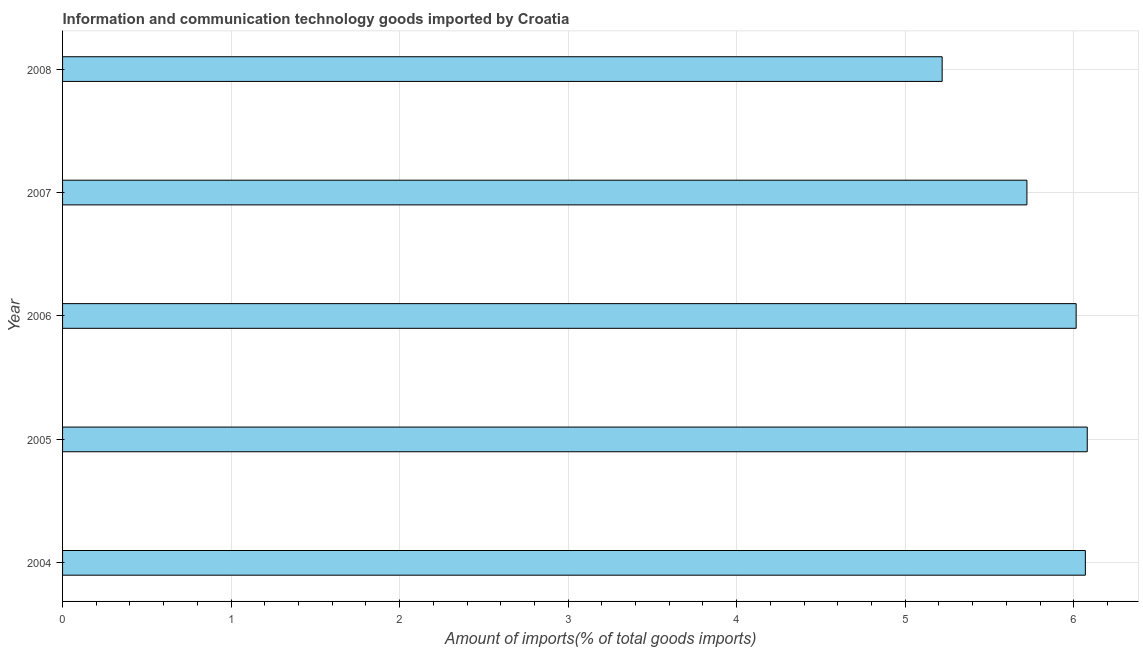Does the graph contain any zero values?
Your answer should be very brief. No. Does the graph contain grids?
Offer a terse response. Yes. What is the title of the graph?
Your answer should be compact. Information and communication technology goods imported by Croatia. What is the label or title of the X-axis?
Your response must be concise. Amount of imports(% of total goods imports). What is the label or title of the Y-axis?
Offer a terse response. Year. What is the amount of ict goods imports in 2007?
Give a very brief answer. 5.72. Across all years, what is the maximum amount of ict goods imports?
Make the answer very short. 6.08. Across all years, what is the minimum amount of ict goods imports?
Ensure brevity in your answer.  5.22. In which year was the amount of ict goods imports maximum?
Keep it short and to the point. 2005. In which year was the amount of ict goods imports minimum?
Provide a succinct answer. 2008. What is the sum of the amount of ict goods imports?
Your response must be concise. 29.11. What is the difference between the amount of ict goods imports in 2007 and 2008?
Your response must be concise. 0.5. What is the average amount of ict goods imports per year?
Offer a very short reply. 5.82. What is the median amount of ict goods imports?
Your response must be concise. 6.01. Do a majority of the years between 2006 and 2007 (inclusive) have amount of ict goods imports greater than 3.8 %?
Keep it short and to the point. Yes. What is the ratio of the amount of ict goods imports in 2004 to that in 2007?
Offer a terse response. 1.06. What is the difference between the highest and the second highest amount of ict goods imports?
Offer a very short reply. 0.01. What is the difference between the highest and the lowest amount of ict goods imports?
Offer a very short reply. 0.86. How many bars are there?
Make the answer very short. 5. Are all the bars in the graph horizontal?
Provide a short and direct response. Yes. How many years are there in the graph?
Keep it short and to the point. 5. What is the difference between two consecutive major ticks on the X-axis?
Offer a terse response. 1. Are the values on the major ticks of X-axis written in scientific E-notation?
Offer a terse response. No. What is the Amount of imports(% of total goods imports) in 2004?
Give a very brief answer. 6.07. What is the Amount of imports(% of total goods imports) of 2005?
Your response must be concise. 6.08. What is the Amount of imports(% of total goods imports) of 2006?
Your response must be concise. 6.01. What is the Amount of imports(% of total goods imports) in 2007?
Make the answer very short. 5.72. What is the Amount of imports(% of total goods imports) in 2008?
Offer a very short reply. 5.22. What is the difference between the Amount of imports(% of total goods imports) in 2004 and 2005?
Your answer should be very brief. -0.01. What is the difference between the Amount of imports(% of total goods imports) in 2004 and 2006?
Your response must be concise. 0.05. What is the difference between the Amount of imports(% of total goods imports) in 2004 and 2007?
Your answer should be compact. 0.35. What is the difference between the Amount of imports(% of total goods imports) in 2004 and 2008?
Keep it short and to the point. 0.85. What is the difference between the Amount of imports(% of total goods imports) in 2005 and 2006?
Keep it short and to the point. 0.07. What is the difference between the Amount of imports(% of total goods imports) in 2005 and 2007?
Ensure brevity in your answer.  0.36. What is the difference between the Amount of imports(% of total goods imports) in 2005 and 2008?
Offer a very short reply. 0.86. What is the difference between the Amount of imports(% of total goods imports) in 2006 and 2007?
Offer a terse response. 0.29. What is the difference between the Amount of imports(% of total goods imports) in 2006 and 2008?
Your answer should be compact. 0.8. What is the difference between the Amount of imports(% of total goods imports) in 2007 and 2008?
Your answer should be very brief. 0.5. What is the ratio of the Amount of imports(% of total goods imports) in 2004 to that in 2005?
Your answer should be very brief. 1. What is the ratio of the Amount of imports(% of total goods imports) in 2004 to that in 2006?
Offer a very short reply. 1.01. What is the ratio of the Amount of imports(% of total goods imports) in 2004 to that in 2007?
Offer a very short reply. 1.06. What is the ratio of the Amount of imports(% of total goods imports) in 2004 to that in 2008?
Keep it short and to the point. 1.16. What is the ratio of the Amount of imports(% of total goods imports) in 2005 to that in 2006?
Give a very brief answer. 1.01. What is the ratio of the Amount of imports(% of total goods imports) in 2005 to that in 2007?
Provide a succinct answer. 1.06. What is the ratio of the Amount of imports(% of total goods imports) in 2005 to that in 2008?
Offer a very short reply. 1.17. What is the ratio of the Amount of imports(% of total goods imports) in 2006 to that in 2007?
Your answer should be very brief. 1.05. What is the ratio of the Amount of imports(% of total goods imports) in 2006 to that in 2008?
Make the answer very short. 1.15. What is the ratio of the Amount of imports(% of total goods imports) in 2007 to that in 2008?
Ensure brevity in your answer.  1.1. 